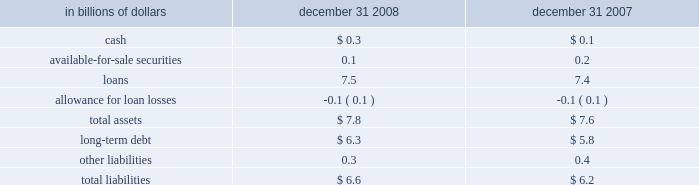On-balance sheet securitizations the company engages in on-balance sheet securitizations .
These are securitizations that do not qualify for sales treatment ; thus , the assets remain on the company 2019s balance sheet .
The table presents the carrying amounts and classification of consolidated assets and liabilities transferred in transactions from the consumer credit card , student loan , mortgage and auto businesses , accounted for as secured borrowings : in billions of dollars december 31 , december 31 .
All assets are restricted from being sold or pledged as collateral .
The cash flows from these assets are the only source used to pay down the associated liabilities , which are non-recourse to the company 2019s general assets .
Citi-administered asset-backed commercial paper conduits the company is active in the asset-backed commercial paper conduit business as administrator of several multi-seller commercial paper conduits , and also as a service provider to single-seller and other commercial paper conduits sponsored by third parties .
The multi-seller commercial paper conduits are designed to provide the company 2019s customers access to low-cost funding in the commercial paper markets .
The conduits purchase assets from or provide financing facilities to customers and are funded by issuing commercial paper to third-party investors .
The conduits generally do not purchase assets originated by the company .
The funding of the conduit is facilitated by the liquidity support and credit enhancements provided by the company and by certain third parties .
As administrator to the conduits , the company is responsible for selecting and structuring of assets purchased or financed by the conduits , making decisions regarding the funding of the conduits , including determining the tenor and other features of the commercial paper issued , monitoring the quality and performance of the conduits 2019 assets , and facilitating the operations and cash flows of the conduits .
In return , the company earns structuring fees from clients for individual transactions and earns an administration fee from the conduit , which is equal to the income from client program and liquidity fees of the conduit after payment of interest costs and other fees .
This administration fee is fairly stable , since most risks and rewards of the underlying assets are passed back to the customers and , once the asset pricing is negotiated , most ongoing income , costs and fees are relatively stable as a percentage of the conduit 2019s size .
The conduits administered by the company do not generally invest in liquid securities that are formally rated by third parties .
The assets are privately negotiated and structured transactions that are designed to be held by the conduit , rather than actively traded and sold .
The yield earned by the conduit on each asset is generally tied to the rate on the commercial paper issued by the conduit , thus passing interest rate risk to the client .
Each asset purchased by the conduit is structured with transaction-specific credit enhancement features provided by the third-party seller , including over- collateralization , cash and excess spread collateral accounts , direct recourse or third-party guarantees .
These credit enhancements are sized with the objective of approximating a credit rating of a or above , based on the company 2019s internal risk ratings .
Substantially all of the funding of the conduits is in the form of short- term commercial paper .
As of december 31 , 2008 , the weighted average life of the commercial paper issued was approximately 37 days .
In addition , the conduits have issued subordinate loss notes and equity with a notional amount of approximately $ 80 million and varying remaining tenors ranging from six months to seven years .
The primary credit enhancement provided to the conduit investors is in the form of transaction-specific credit enhancement described above .
In addition , there are two additional forms of credit enhancement that protect the commercial paper investors from defaulting assets .
First , the subordinate loss notes issued by each conduit absorb any credit losses up to their full notional amount .
It is expected that the subordinate loss notes issued by each conduit are sufficient to absorb a majority of the expected losses from each conduit , thereby making the single investor in the subordinate loss note the primary beneficiary under fin 46 ( r ) .
Second , each conduit has obtained a letter of credit from the company , which is generally 8-10% ( 8-10 % ) of the conduit 2019s assets .
The letters of credit provided by the company total approximately $ 5.8 billion and are included in the company 2019s maximum exposure to loss .
The net result across all multi-seller conduits administered by the company is that , in the event of defaulted assets in excess of the transaction-specific credit enhancement described above , any losses in each conduit are allocated in the following order : 2022 subordinate loss note holders 2022 the company 2022 the commercial paper investors the company , along with third parties , also provides the conduits with two forms of liquidity agreements that are used to provide funding to the conduits in the event of a market disruption , among other events .
Each asset of the conduit is supported by a transaction-specific liquidity facility in the form of an asset purchase agreement ( apa ) .
Under the apa , the company has agreed to purchase non-defaulted eligible receivables from the conduit at par .
Any assets purchased under the apa are subject to increased pricing .
The apa is not designed to provide credit support to the conduit , as it generally does not permit the purchase of defaulted or impaired assets and generally reprices the assets purchased to consider potential increased credit risk .
The apa covers all assets in the conduits and is considered in the company 2019s maximum exposure to loss .
In addition , the company provides the conduits with program-wide liquidity in the form of short-term lending commitments .
Under these commitments , the company has agreed to lend to the conduits in the event of a short-term disruption in the commercial paper market , subject to specified conditions .
The total notional exposure under the program-wide liquidity agreement is $ 11.3 billion and is considered in the company 2019s maximum exposure to loss .
The company receives fees for providing both types of liquidity agreement and considers these fees to be on fair market terms. .
What was the change in billions of the available-for-sale securities between 2007 and 2008? 
Computations: (0.1 - 0.2)
Answer: -0.1. 